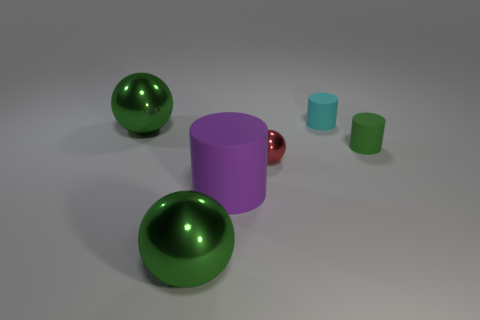Add 3 big gray shiny spheres. How many objects exist? 9 Add 3 large green metallic spheres. How many large green metallic spheres are left? 5 Add 2 tiny green rubber cylinders. How many tiny green rubber cylinders exist? 3 Subtract 1 purple cylinders. How many objects are left? 5 Subtract all matte things. Subtract all big purple cylinders. How many objects are left? 2 